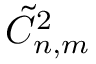<formula> <loc_0><loc_0><loc_500><loc_500>\tilde { C } _ { n , m } ^ { 2 }</formula> 